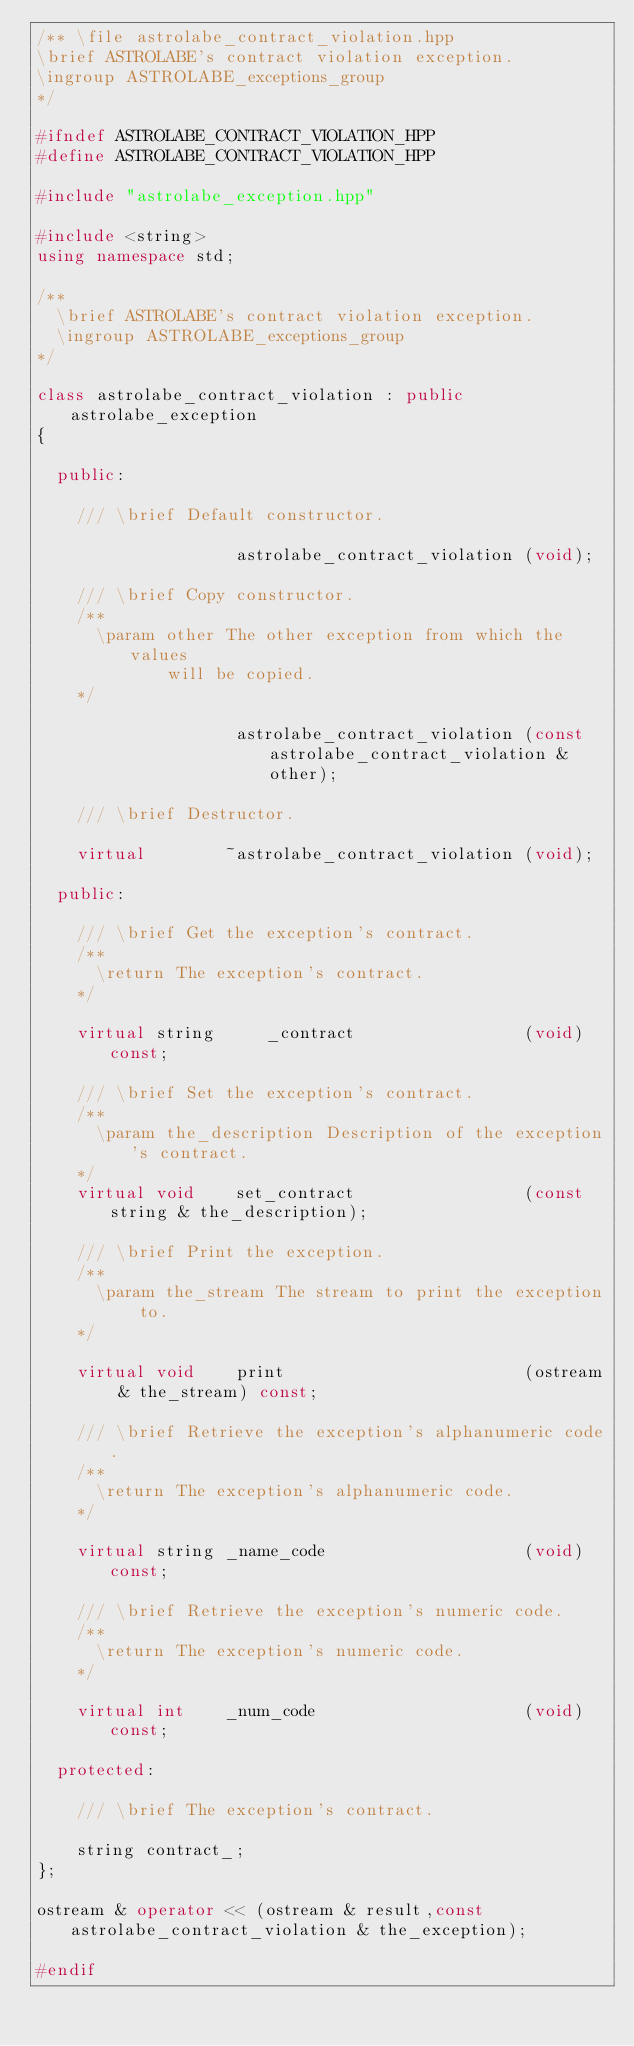Convert code to text. <code><loc_0><loc_0><loc_500><loc_500><_C++_>/** \file astrolabe_contract_violation.hpp
\brief ASTROLABE's contract violation exception.
\ingroup ASTROLABE_exceptions_group
*/

#ifndef ASTROLABE_CONTRACT_VIOLATION_HPP
#define ASTROLABE_CONTRACT_VIOLATION_HPP

#include "astrolabe_exception.hpp"

#include <string>
using namespace std;

/**
  \brief ASTROLABE's contract violation exception.
  \ingroup ASTROLABE_exceptions_group
*/

class astrolabe_contract_violation : public astrolabe_exception
{

  public:

    /// \brief Default constructor.

                    astrolabe_contract_violation (void);

    /// \brief Copy constructor.
    /**
      \param other The other exception from which the values
             will be copied.
    */

                    astrolabe_contract_violation (const astrolabe_contract_violation & other);

    /// \brief Destructor.

    virtual        ~astrolabe_contract_violation (void);

  public:

    /// \brief Get the exception's contract.
    /**
      \return The exception's contract.
    */

    virtual string     _contract                 (void) const;

    /// \brief Set the exception's contract.
    /**
      \param the_description Description of the exception's contract.
    */
    virtual void    set_contract                 (const string & the_description);

    /// \brief Print the exception.
    /**
      \param the_stream The stream to print the exception to.
    */

    virtual void    print                        (ostream & the_stream) const;

    /// \brief Retrieve the exception's alphanumeric code.
    /**
      \return The exception's alphanumeric code.
    */

    virtual string _name_code                    (void) const;

    /// \brief Retrieve the exception's numeric code.
    /**
      \return The exception's numeric code.
    */

    virtual int    _num_code                     (void) const;

  protected:

    /// \brief The exception's contract.

    string contract_;
};

ostream & operator << (ostream & result,const astrolabe_contract_violation & the_exception);

#endif
</code> 